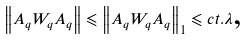<formula> <loc_0><loc_0><loc_500><loc_500>\left \| A _ { q } W _ { q } A _ { q } \right \| \leqslant \left \| A _ { q } W _ { q } A _ { q } \right \| _ { 1 } \leqslant c t . \lambda \text {,}</formula> 